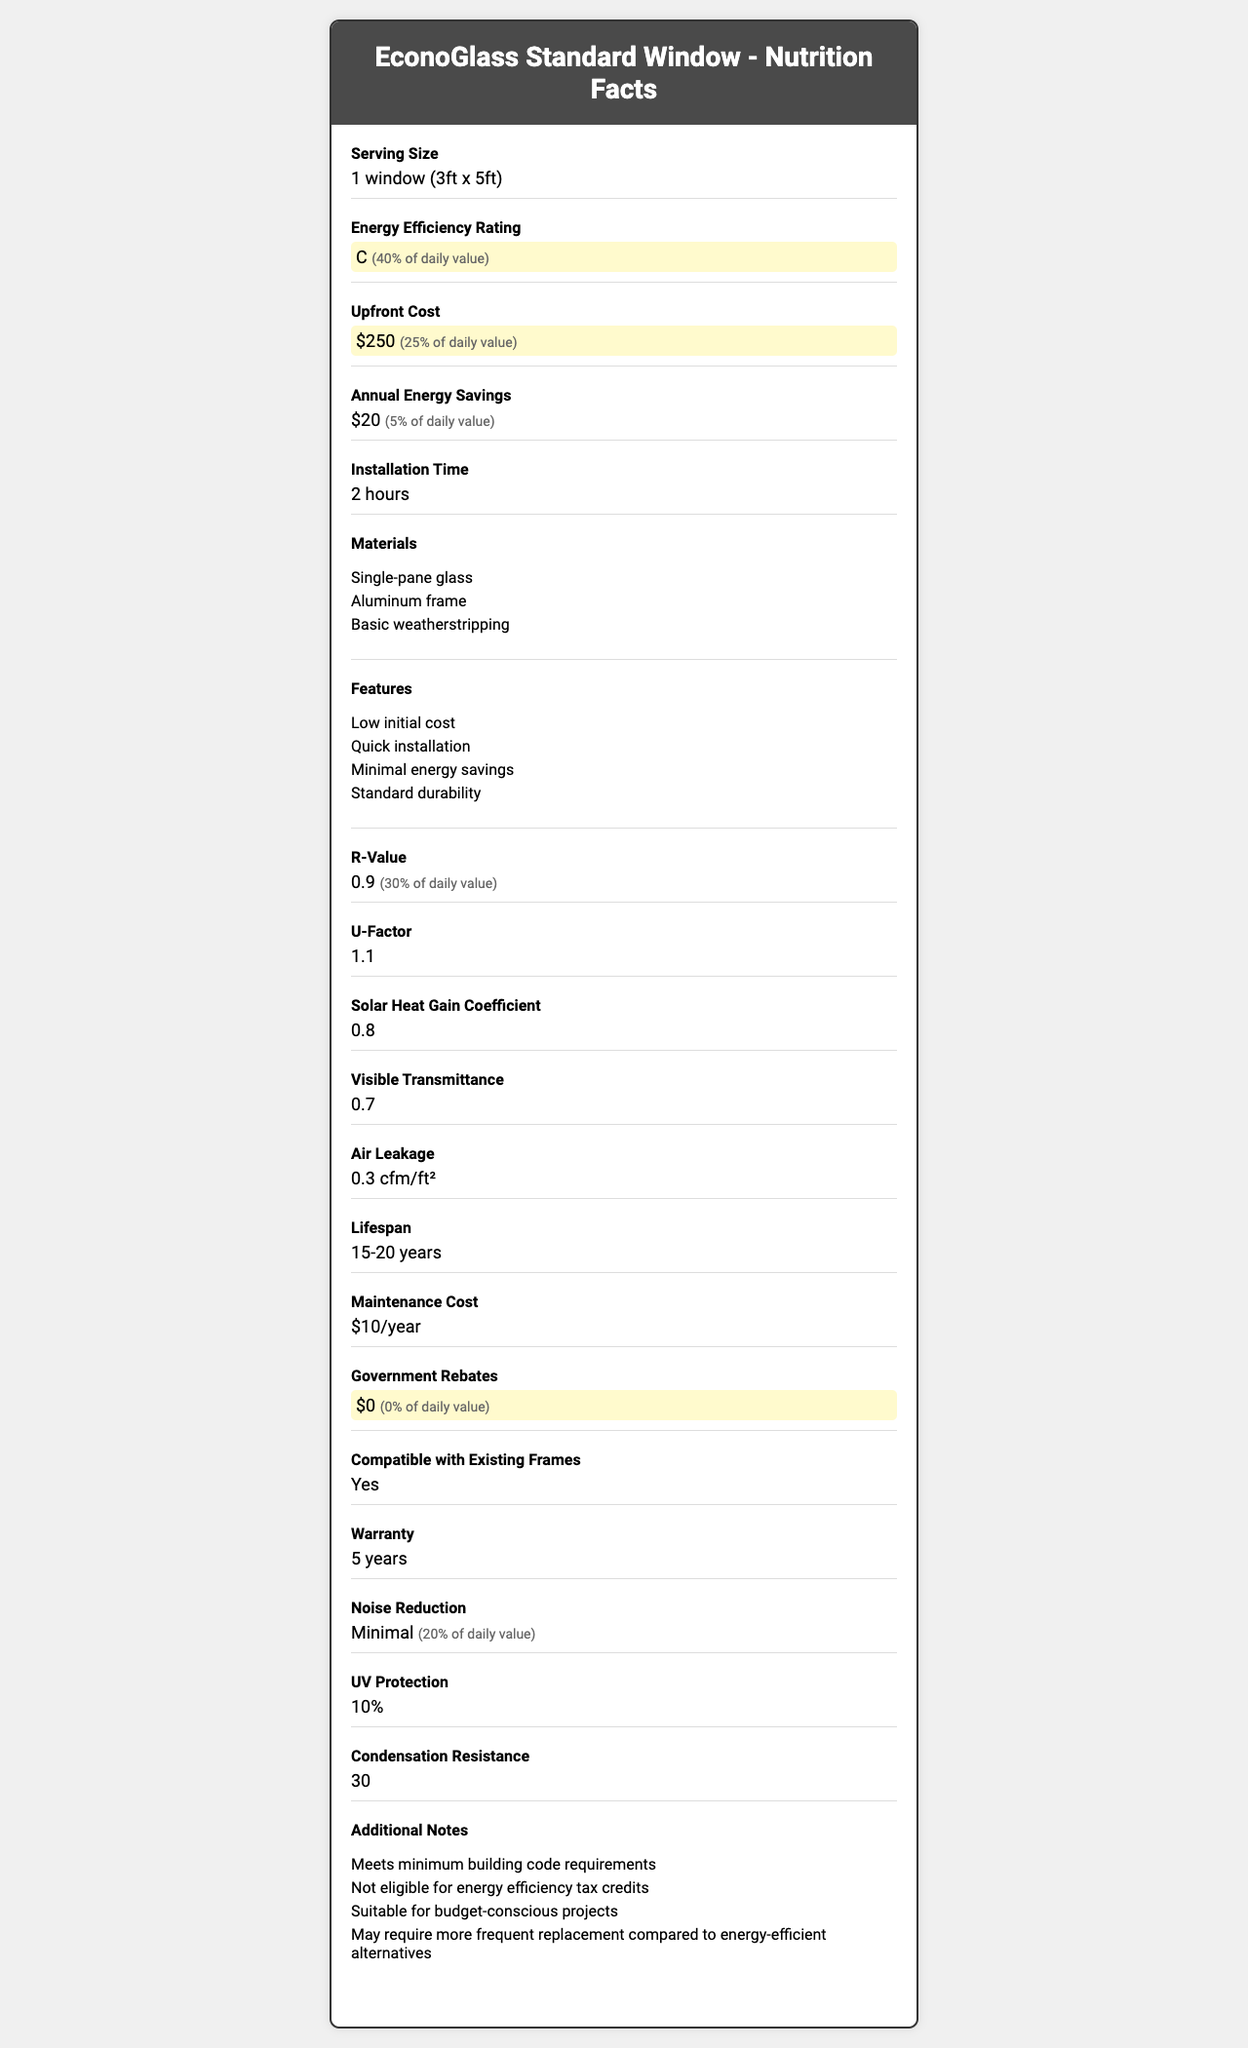what is the serving size of the EconoGlass Standard Window? The serving size is listed as "1 window (3ft x 5ft)" in the document.
Answer: 1 window (3ft x 5ft) how much does the EconoGlass Standard Window cost up front? The upfront cost is indicated as "$250".
Answer: $250 what is the energy efficiency rating of the EconoGlass Standard Window? The energy efficiency rating is listed as "C".
Answer: C how much annual energy savings does the EconoGlass Standard Window provide? The annual energy savings is listed as "$20".
Answer: $20 which materials are used in the EconoGlass Standard Window? The materials listed are "Single-pane glass, Aluminum frame, Basic weatherstripping".
Answer: Single-pane glass, Aluminum frame, Basic weatherstripping what is the r-value of the EconoGlass Standard Window? The R-Value is given as "0.9".
Answer: 0.9 what is the warranty period for the EconoGlass Standard Window? The warranty period is stated as "5 years".
Answer: 5 years how long is the installation time for the EconoGlass Standard Window? The installation time is indicated as "2 hours".
Answer: 2 hours what are the main features highlighted for the EconoGlass Standard Window? The features listed are "Low initial cost, Quick installation, Minimal energy savings, Standard durability".
Answer: Low initial cost, Quick installation, Minimal energy savings, Standard durability of the following, which benefit is NOT provided by the EconoGlass Standard Window? A. Government rebates B. UV protection C. Compatibility with existing frames D. Energy efficiency tax credits The document notes "$0" in government rebates and mentions that it is not eligible for energy efficiency tax credits.
Answer: A what is the daily value percentage for upfront cost? A. 25% B. 30% C. 40% D. 5% The daily value percentage for upfront cost is listed as "25%".
Answer: A does the EconoGlass Standard Window provide significant noise reduction? The document mentions "Minimal" noise reduction.
Answer: No what is the overall aim or main idea of the document? The document outlines various attributes, costs, and performance metrics of the EconoGlass Standard Window, favoring its affordability and minimal installation hassle.
Answer: To provide technical details and advantages of the EconoGlass Standard Window, highlighting its lower upfront cost, quick installation, and basic energy efficiency, suitable for budget-conscious projects. what government rebates are available for the EconoGlass Standard Window? The document clearly indicates that there are no government rebates available.
Answer: $0 how durable is the EconoGlass Standard Window compared to energy-efficient alternatives? According to the document, it states "Standard durability" and "May require more frequent replacement compared to energy-efficient alternatives."
Answer: Standard durability, may require more frequent replacement what type of weatherstripping is used in the EconoGlass Standard Window? The document only mentions "Basic weatherstripping" without specifying the type.
Answer: Cannot be determined 